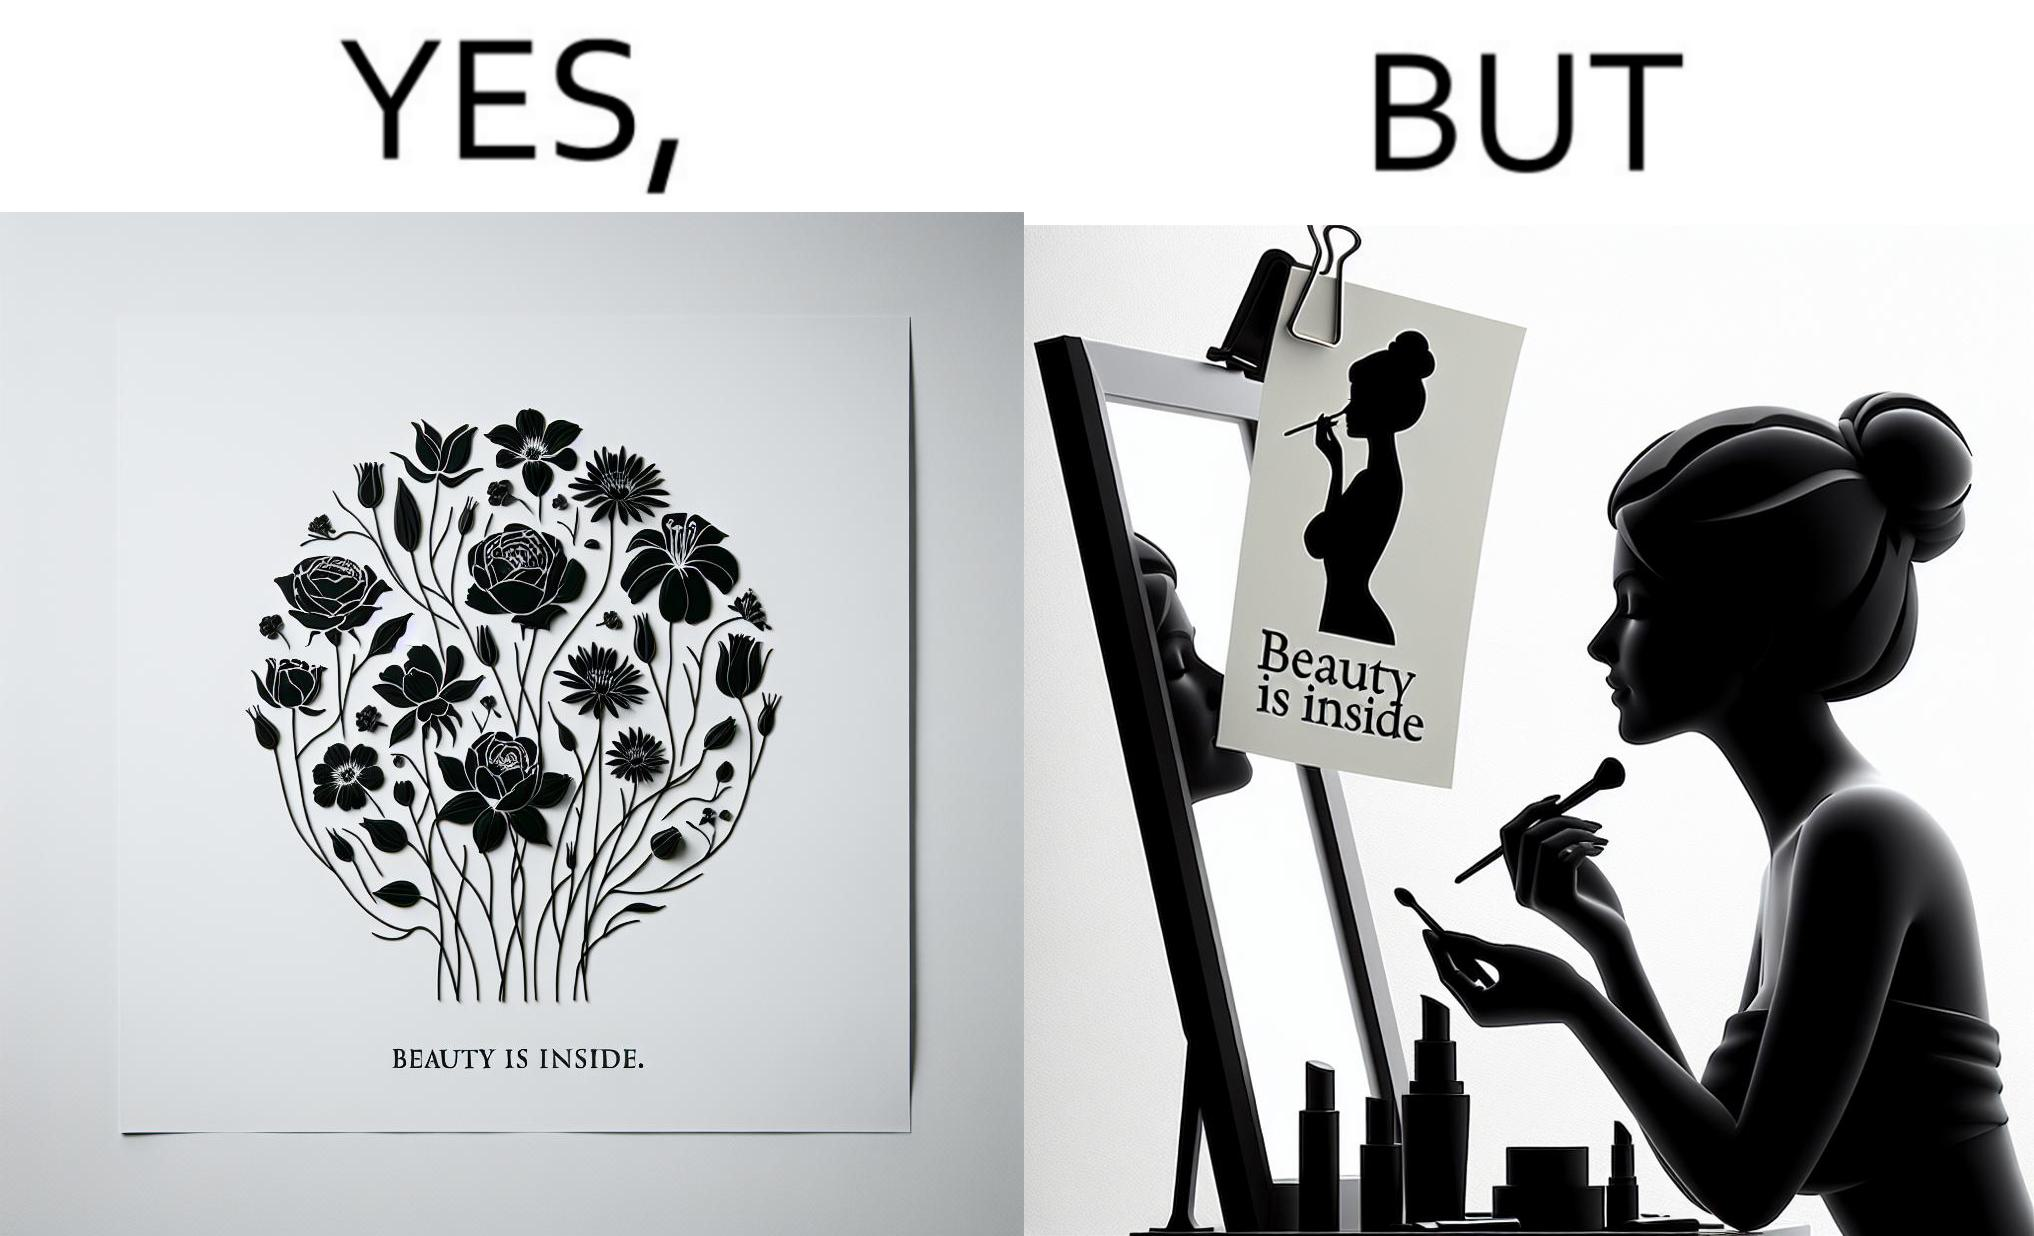Describe what you see in this image. The image is satirical because while the text on the paper says that beauty lies inside, the woman ignores the note and continues to apply makeup to improve her outer beauty. 